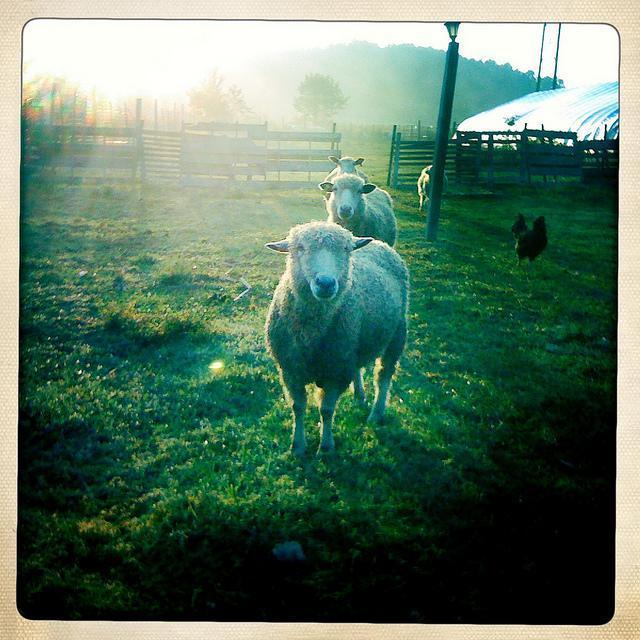How many chickens are there?
Give a very brief answer. 1. How many sheep can you see?
Give a very brief answer. 2. How many man wear speces?
Give a very brief answer. 0. 